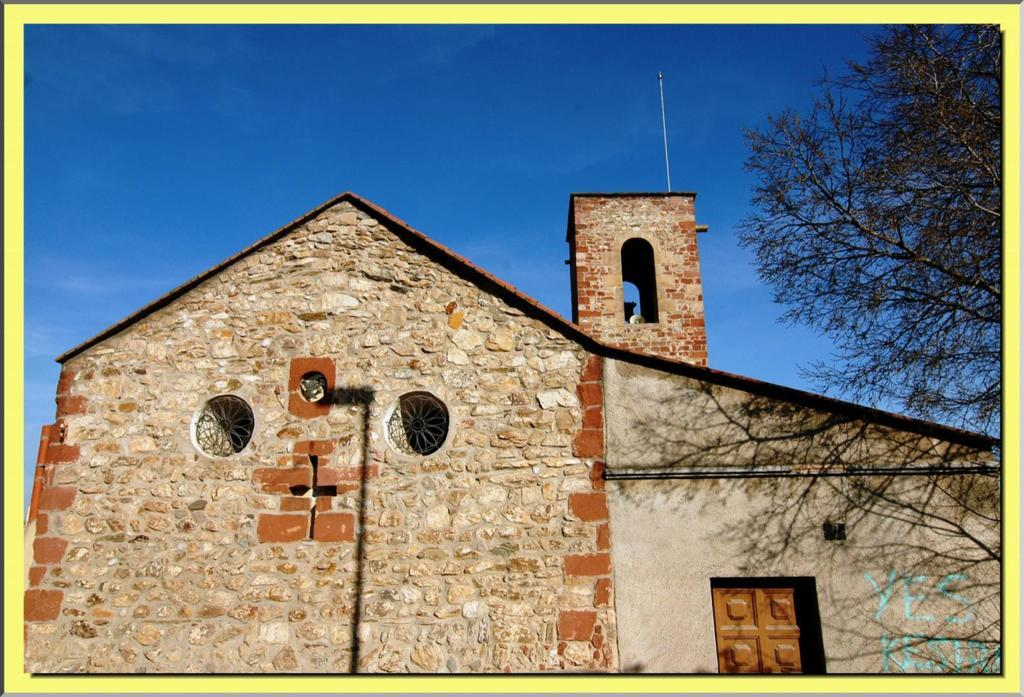What type of structure is in the picture? There is a house in the picture. What part of the house can be seen in the picture? There is a door in the picture. What type of vegetation is visible in the picture? There are trees in the picture. What is visible in the background of the picture? The sky is visible in the background of the picture. What type of riddle is being solved by the trees in the picture? There is no riddle being solved by the trees in the picture; they are simply trees in the background. 